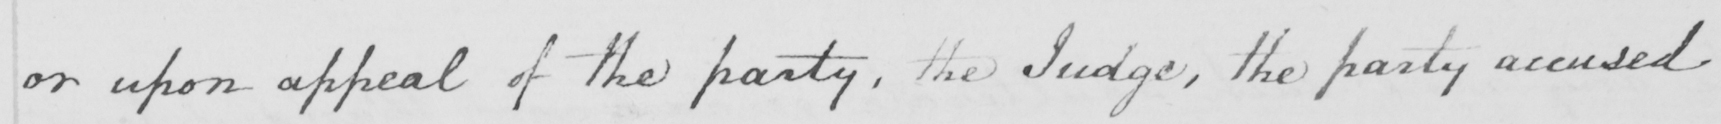What text is written in this handwritten line? or upon appeal of the party , the Judge , the party accused 